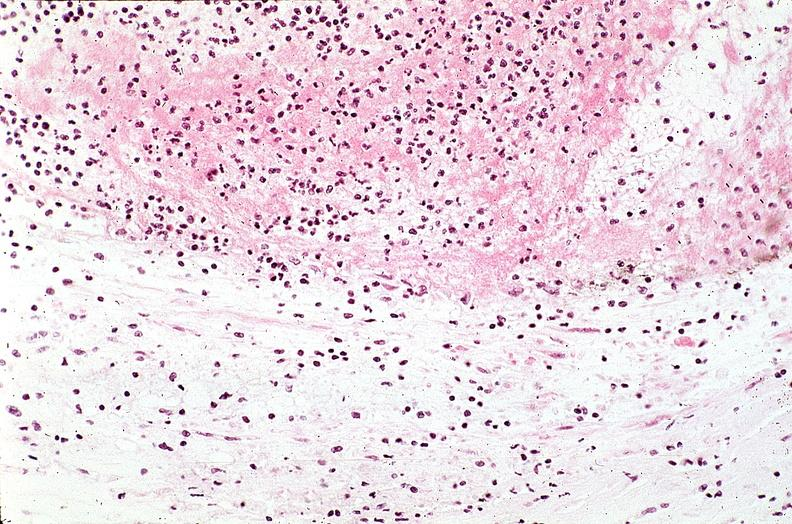how does this image show coronary artery?
Answer the question using a single word or phrase. With atherosclerosis and thrombotic occlusion 